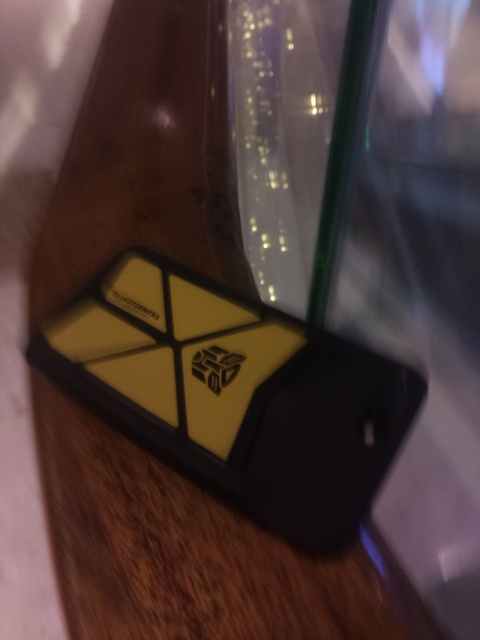What does the presence of a Transformers-themed phone case suggest about the owner's interests? The Transformers-themed phone case indicates that the owner may be a fan of the Transformers media franchise, which includes toys, movies, and comics centered around sentient robots. 